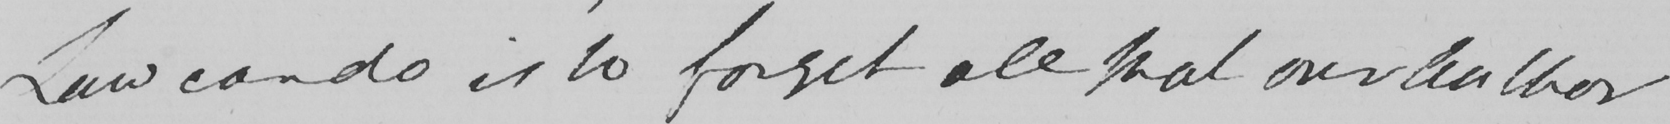Can you tell me what this handwritten text says? Law can do is to forget all that our Author 